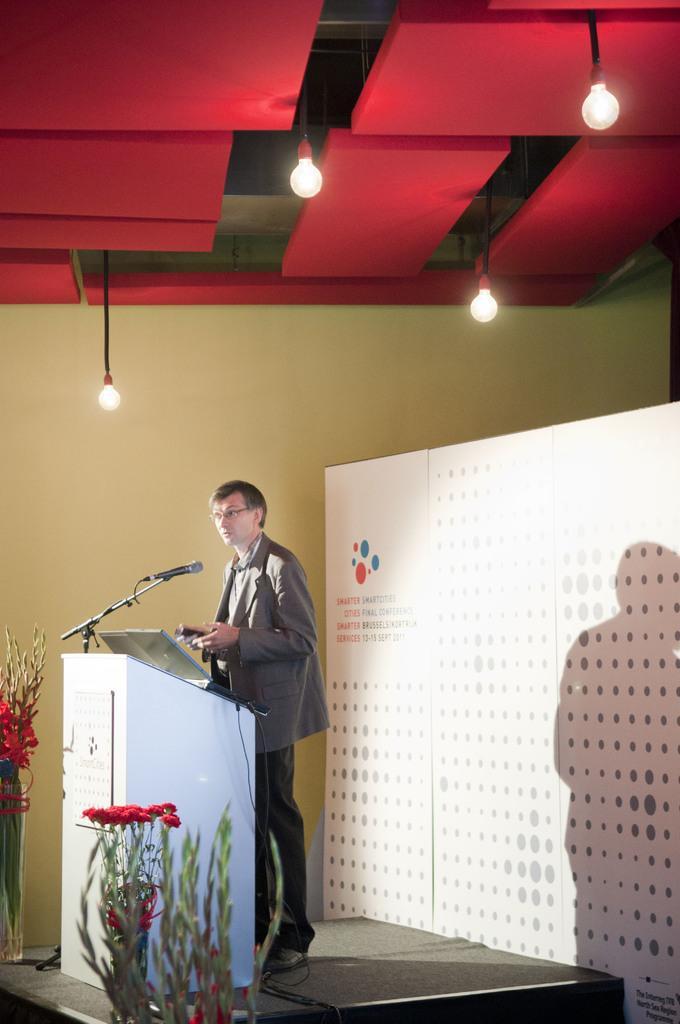In one or two sentences, can you explain what this image depicts? In this image, we can see a person near the podium and standing on a stage. He is holding an object. We can see decorative flowers. In the background, there is a wall and banner. At the top of the image, we can see the ceiling and lights, rods and some objects. 